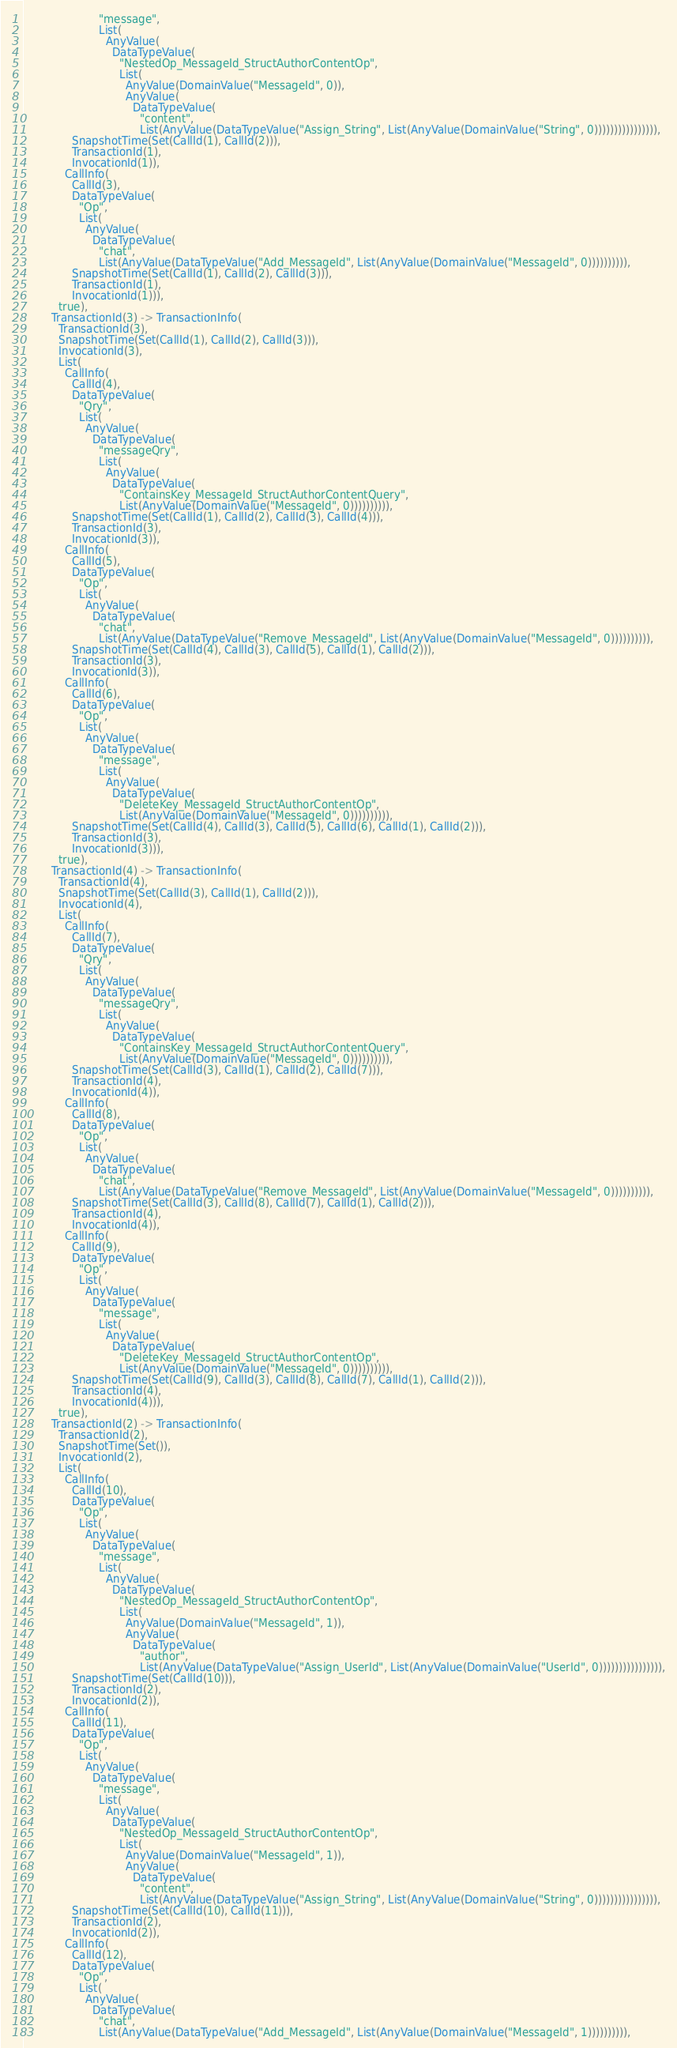Convert code to text. <code><loc_0><loc_0><loc_500><loc_500><_Scala_>                      "message",
                      List(
                        AnyValue(
                          DataTypeValue(
                            "NestedOp_MessageId_StructAuthorContentOp",
                            List(
                              AnyValue(DomainValue("MessageId", 0)),
                              AnyValue(
                                DataTypeValue(
                                  "content",
                                  List(AnyValue(DataTypeValue("Assign_String", List(AnyValue(DomainValue("String", 0)))))))))))))))),
              SnapshotTime(Set(CallId(1), CallId(2))),
              TransactionId(1),
              InvocationId(1)),
            CallInfo(
              CallId(3),
              DataTypeValue(
                "Op",
                List(
                  AnyValue(
                    DataTypeValue(
                      "chat",
                      List(AnyValue(DataTypeValue("Add_MessageId", List(AnyValue(DomainValue("MessageId", 0)))))))))),
              SnapshotTime(Set(CallId(1), CallId(2), CallId(3))),
              TransactionId(1),
              InvocationId(1))),
          true),
        TransactionId(3) -> TransactionInfo(
          TransactionId(3),
          SnapshotTime(Set(CallId(1), CallId(2), CallId(3))),
          InvocationId(3),
          List(
            CallInfo(
              CallId(4),
              DataTypeValue(
                "Qry",
                List(
                  AnyValue(
                    DataTypeValue(
                      "messageQry",
                      List(
                        AnyValue(
                          DataTypeValue(
                            "ContainsKey_MessageId_StructAuthorContentQuery",
                            List(AnyValue(DomainValue("MessageId", 0)))))))))),
              SnapshotTime(Set(CallId(1), CallId(2), CallId(3), CallId(4))),
              TransactionId(3),
              InvocationId(3)),
            CallInfo(
              CallId(5),
              DataTypeValue(
                "Op",
                List(
                  AnyValue(
                    DataTypeValue(
                      "chat",
                      List(AnyValue(DataTypeValue("Remove_MessageId", List(AnyValue(DomainValue("MessageId", 0)))))))))),
              SnapshotTime(Set(CallId(4), CallId(3), CallId(5), CallId(1), CallId(2))),
              TransactionId(3),
              InvocationId(3)),
            CallInfo(
              CallId(6),
              DataTypeValue(
                "Op",
                List(
                  AnyValue(
                    DataTypeValue(
                      "message",
                      List(
                        AnyValue(
                          DataTypeValue(
                            "DeleteKey_MessageId_StructAuthorContentOp",
                            List(AnyValue(DomainValue("MessageId", 0)))))))))),
              SnapshotTime(Set(CallId(4), CallId(3), CallId(5), CallId(6), CallId(1), CallId(2))),
              TransactionId(3),
              InvocationId(3))),
          true),
        TransactionId(4) -> TransactionInfo(
          TransactionId(4),
          SnapshotTime(Set(CallId(3), CallId(1), CallId(2))),
          InvocationId(4),
          List(
            CallInfo(
              CallId(7),
              DataTypeValue(
                "Qry",
                List(
                  AnyValue(
                    DataTypeValue(
                      "messageQry",
                      List(
                        AnyValue(
                          DataTypeValue(
                            "ContainsKey_MessageId_StructAuthorContentQuery",
                            List(AnyValue(DomainValue("MessageId", 0)))))))))),
              SnapshotTime(Set(CallId(3), CallId(1), CallId(2), CallId(7))),
              TransactionId(4),
              InvocationId(4)),
            CallInfo(
              CallId(8),
              DataTypeValue(
                "Op",
                List(
                  AnyValue(
                    DataTypeValue(
                      "chat",
                      List(AnyValue(DataTypeValue("Remove_MessageId", List(AnyValue(DomainValue("MessageId", 0)))))))))),
              SnapshotTime(Set(CallId(3), CallId(8), CallId(7), CallId(1), CallId(2))),
              TransactionId(4),
              InvocationId(4)),
            CallInfo(
              CallId(9),
              DataTypeValue(
                "Op",
                List(
                  AnyValue(
                    DataTypeValue(
                      "message",
                      List(
                        AnyValue(
                          DataTypeValue(
                            "DeleteKey_MessageId_StructAuthorContentOp",
                            List(AnyValue(DomainValue("MessageId", 0)))))))))),
              SnapshotTime(Set(CallId(9), CallId(3), CallId(8), CallId(7), CallId(1), CallId(2))),
              TransactionId(4),
              InvocationId(4))),
          true),
        TransactionId(2) -> TransactionInfo(
          TransactionId(2),
          SnapshotTime(Set()),
          InvocationId(2),
          List(
            CallInfo(
              CallId(10),
              DataTypeValue(
                "Op",
                List(
                  AnyValue(
                    DataTypeValue(
                      "message",
                      List(
                        AnyValue(
                          DataTypeValue(
                            "NestedOp_MessageId_StructAuthorContentOp",
                            List(
                              AnyValue(DomainValue("MessageId", 1)),
                              AnyValue(
                                DataTypeValue(
                                  "author",
                                  List(AnyValue(DataTypeValue("Assign_UserId", List(AnyValue(DomainValue("UserId", 0)))))))))))))))),
              SnapshotTime(Set(CallId(10))),
              TransactionId(2),
              InvocationId(2)),
            CallInfo(
              CallId(11),
              DataTypeValue(
                "Op",
                List(
                  AnyValue(
                    DataTypeValue(
                      "message",
                      List(
                        AnyValue(
                          DataTypeValue(
                            "NestedOp_MessageId_StructAuthorContentOp",
                            List(
                              AnyValue(DomainValue("MessageId", 1)),
                              AnyValue(
                                DataTypeValue(
                                  "content",
                                  List(AnyValue(DataTypeValue("Assign_String", List(AnyValue(DomainValue("String", 0)))))))))))))))),
              SnapshotTime(Set(CallId(10), CallId(11))),
              TransactionId(2),
              InvocationId(2)),
            CallInfo(
              CallId(12),
              DataTypeValue(
                "Op",
                List(
                  AnyValue(
                    DataTypeValue(
                      "chat",
                      List(AnyValue(DataTypeValue("Add_MessageId", List(AnyValue(DomainValue("MessageId", 1)))))))))),</code> 